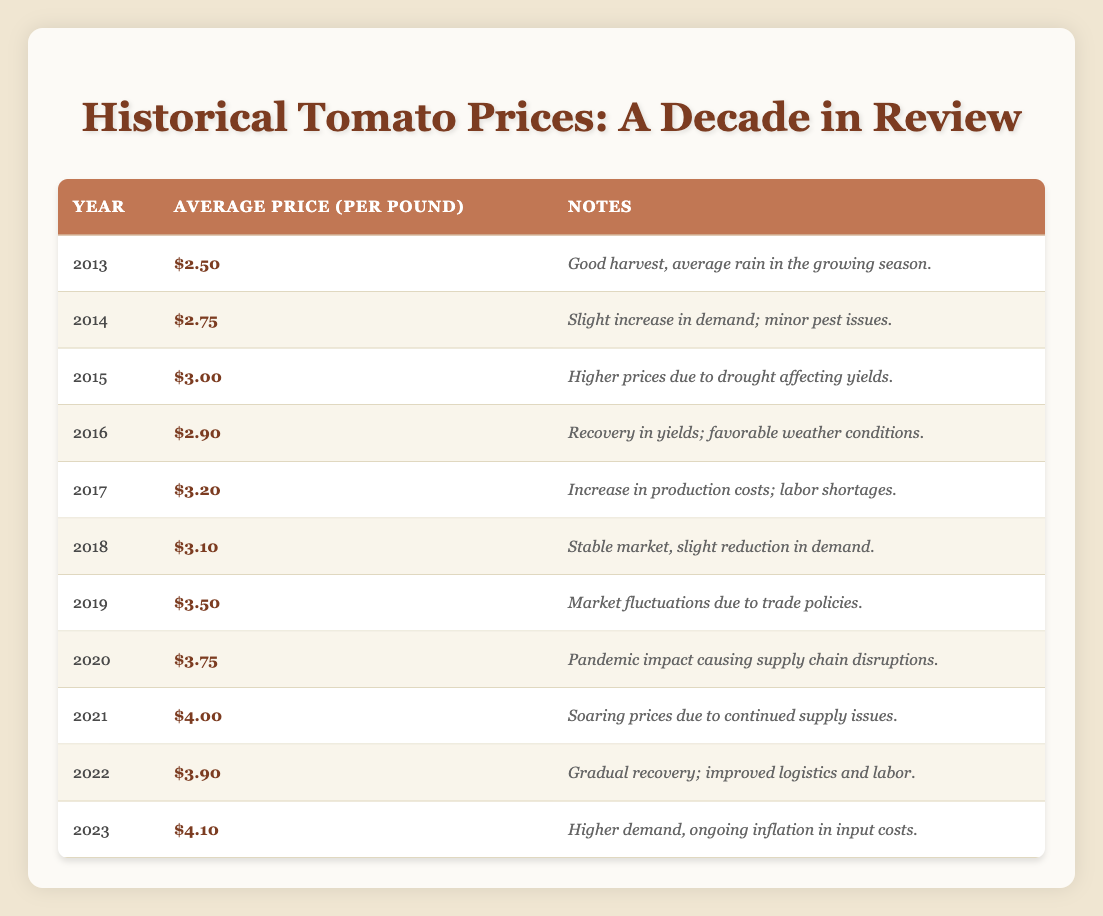What was the average price of tomatoes in 2013? The table shows that the average price per pound of tomatoes in 2013 was listed directly in the row for that year, which is $2.50.
Answer: $2.50 What year had the highest average price for tomatoes? By examining the average prices listed in the table, the year with the highest price is 2021, where the average price per pound reached $4.00, which is the maximum price.
Answer: 2021 What was the average price per pound of tomatoes in 2015 and 2020 combined? The average price in 2015 was $3.00 and in 2020 was $3.75. To find the average, we sum these two prices ($3.00 + $3.75 = $6.75) and divide by 2 to get $3.375 as the average price for these two years.
Answer: $3.38 (rounded) Was there a year when the average price decreased from the previous year? Analyzing the prices from year to year, in 2016, the average price decreased from $3.00 in 2015 to $2.90 in 2016. This confirms that there was indeed a decrease.
Answer: Yes How much did the average price of tomatoes rise from 2019 to 2021? The average price in 2019 was $3.50 and in 2021 it was $4.00. To find the increase, we subtract the lower value from the higher value ($4.00 - $3.50 = $0.50). This tells us the price rose by $0.50 in this time frame.
Answer: $0.50 